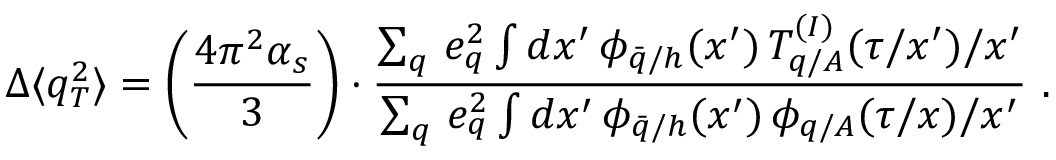Convert formula to latex. <formula><loc_0><loc_0><loc_500><loc_500>\Delta \langle q _ { T } ^ { 2 } \rangle = \left ( \frac { 4 \pi ^ { 2 } \alpha _ { s } } { 3 } \right ) \cdot \frac { \sum _ { q } \, e _ { q } ^ { 2 } \int d x ^ { \prime } \, \phi _ { \bar { q } / h } ( x ^ { \prime } ) \, T _ { q / A } ^ { ( I ) } ( \tau / x ^ { \prime } ) / x ^ { \prime } } { \sum _ { q } \, e _ { q } ^ { 2 } \int d x ^ { \prime } \, \phi _ { \bar { q } / h } ( x ^ { \prime } ) \, \phi _ { q / A } ( \tau / x ) / x ^ { \prime } } \ .</formula> 